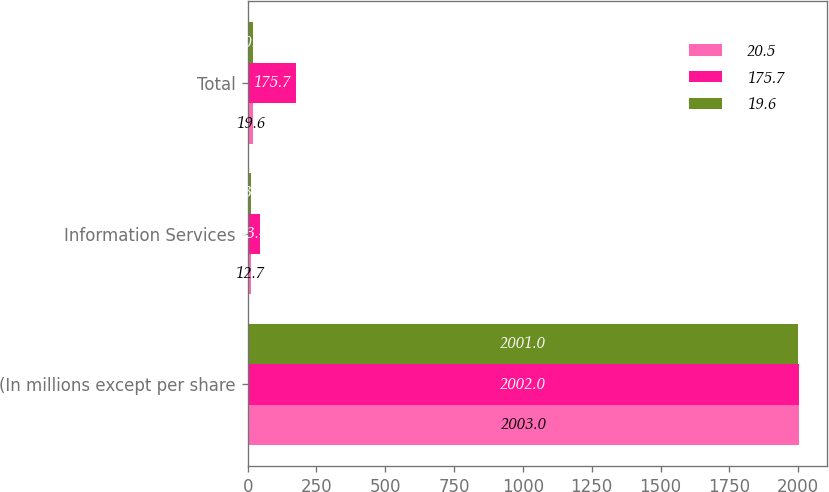Convert chart to OTSL. <chart><loc_0><loc_0><loc_500><loc_500><stacked_bar_chart><ecel><fcel>(In millions except per share<fcel>Information Services<fcel>Total<nl><fcel>20.5<fcel>2003<fcel>12.7<fcel>19.6<nl><fcel>175.7<fcel>2002<fcel>43.4<fcel>175.7<nl><fcel>19.6<fcel>2001<fcel>13.2<fcel>20.5<nl></chart> 